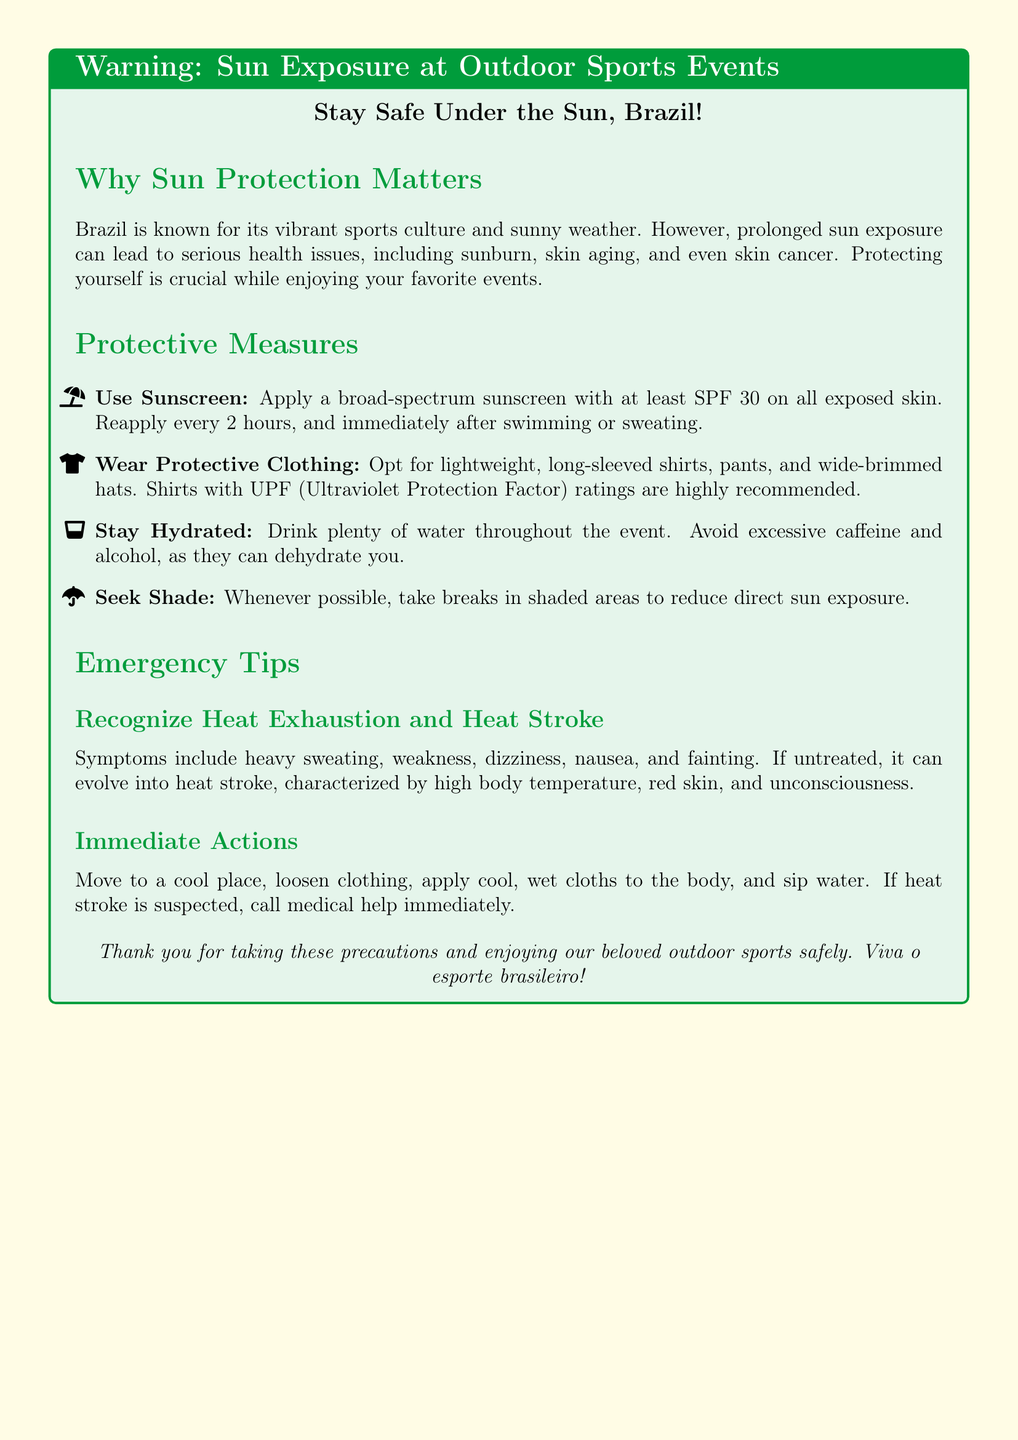What is the recommended SPF for sunscreen? The document states to use a broad-spectrum sunscreen with at least SPF 30.
Answer: SPF 30 What should you wear for sun protection? The document recommends lightweight, long-sleeved shirts, pants, and wide-brimmed hats for sun protection.
Answer: Protective clothing How often should you reapply sunscreen? It is advised to reapply sunscreen every 2 hours.
Answer: Every 2 hours What are symptoms of heat exhaustion? Symptoms include heavy sweating, weakness, dizziness, nausea, and fainting according to the document.
Answer: Heavy sweating, weakness, dizziness, nausea, fainting What should you do if heat stroke is suspected? The document suggests calling medical help immediately if heat stroke is suspected.
Answer: Call medical help What color scheme is used for the warning label? The color scheme includes shades of green and yellow, representing the Brazilian flag.
Answer: Green and yellow What is the purpose of the warning label? The warning label educates attendees about the potential dangers of prolonged sun exposure during outdoor sports events.
Answer: Educate attendees Where should you take breaks during an event? The document advises seeking shade to reduce direct sun exposure whenever possible.
Answer: In shaded areas 